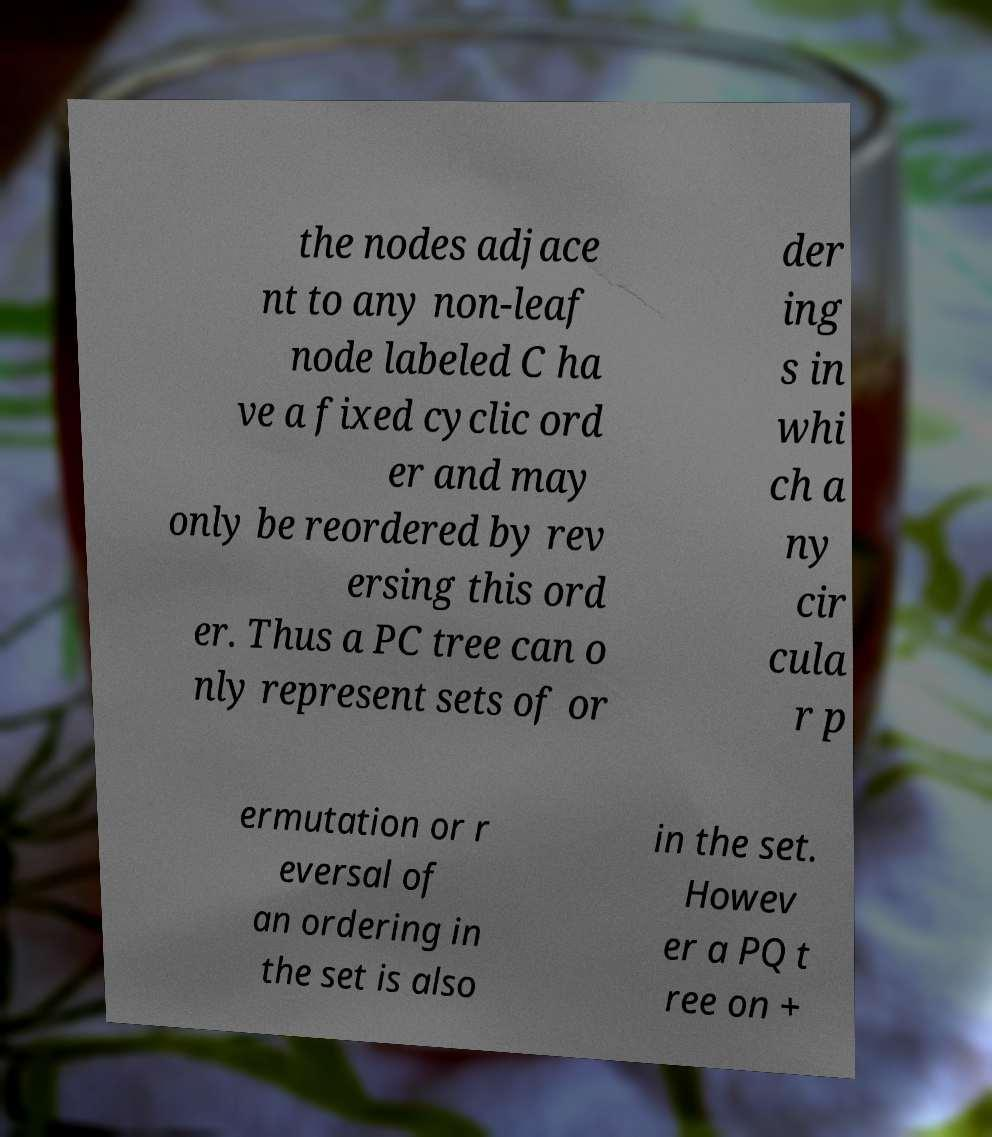For documentation purposes, I need the text within this image transcribed. Could you provide that? the nodes adjace nt to any non-leaf node labeled C ha ve a fixed cyclic ord er and may only be reordered by rev ersing this ord er. Thus a PC tree can o nly represent sets of or der ing s in whi ch a ny cir cula r p ermutation or r eversal of an ordering in the set is also in the set. Howev er a PQ t ree on + 